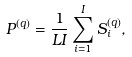<formula> <loc_0><loc_0><loc_500><loc_500>P ^ { ( q ) } = \frac { 1 } { L I } \sum _ { i = 1 } ^ { I } { S _ { i } ^ { ( q ) } } ,</formula> 